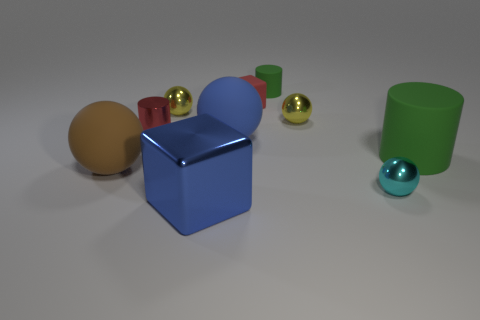What size is the red object right of the small red object in front of the red block?
Provide a short and direct response. Small. There is a green rubber thing right of the tiny object in front of the green thing in front of the small rubber cylinder; what is its size?
Provide a succinct answer. Large. Does the small yellow metallic object to the left of the blue rubber ball have the same shape as the matte thing in front of the large cylinder?
Your answer should be very brief. Yes. What number of other things are there of the same color as the large block?
Give a very brief answer. 1. There is a object that is right of the cyan object; does it have the same size as the big blue metallic block?
Ensure brevity in your answer.  Yes. Does the big blue object that is in front of the big brown object have the same material as the large blue thing that is behind the blue cube?
Give a very brief answer. No. Is there a blue rubber thing of the same size as the red shiny cylinder?
Provide a short and direct response. No. What shape is the yellow metal object that is behind the tiny yellow metal sphere on the right side of the cube in front of the brown sphere?
Ensure brevity in your answer.  Sphere. Is the number of big objects in front of the large green rubber thing greater than the number of tiny cyan metal balls?
Keep it short and to the point. Yes. Are there any tiny blue shiny things of the same shape as the tiny red rubber object?
Your answer should be compact. No. 